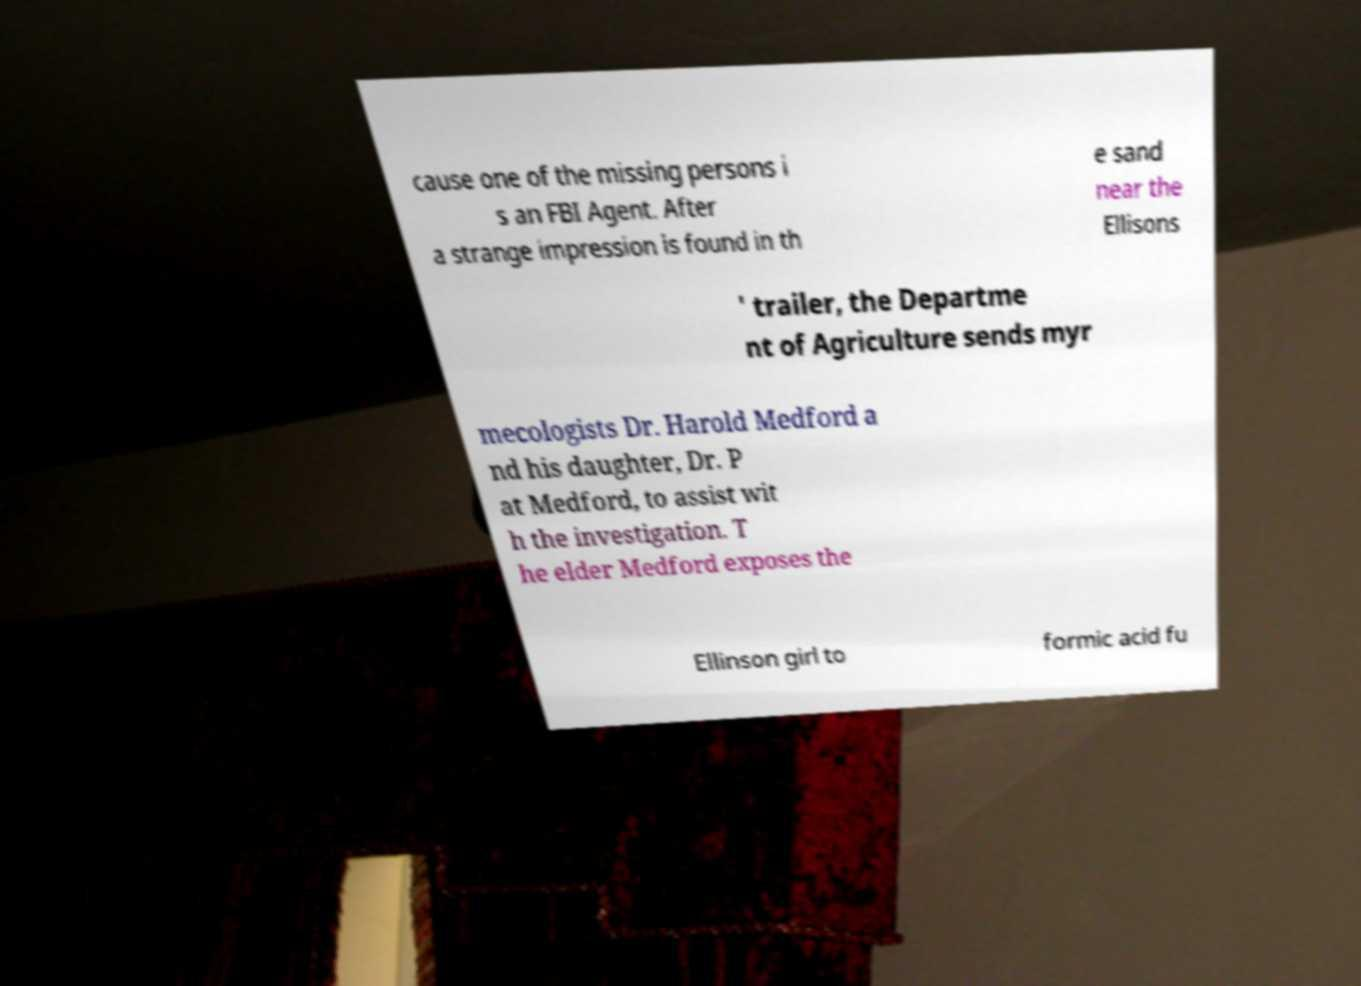Can you accurately transcribe the text from the provided image for me? cause one of the missing persons i s an FBI Agent. After a strange impression is found in th e sand near the Ellisons ' trailer, the Departme nt of Agriculture sends myr mecologists Dr. Harold Medford a nd his daughter, Dr. P at Medford, to assist wit h the investigation. T he elder Medford exposes the Ellinson girl to formic acid fu 